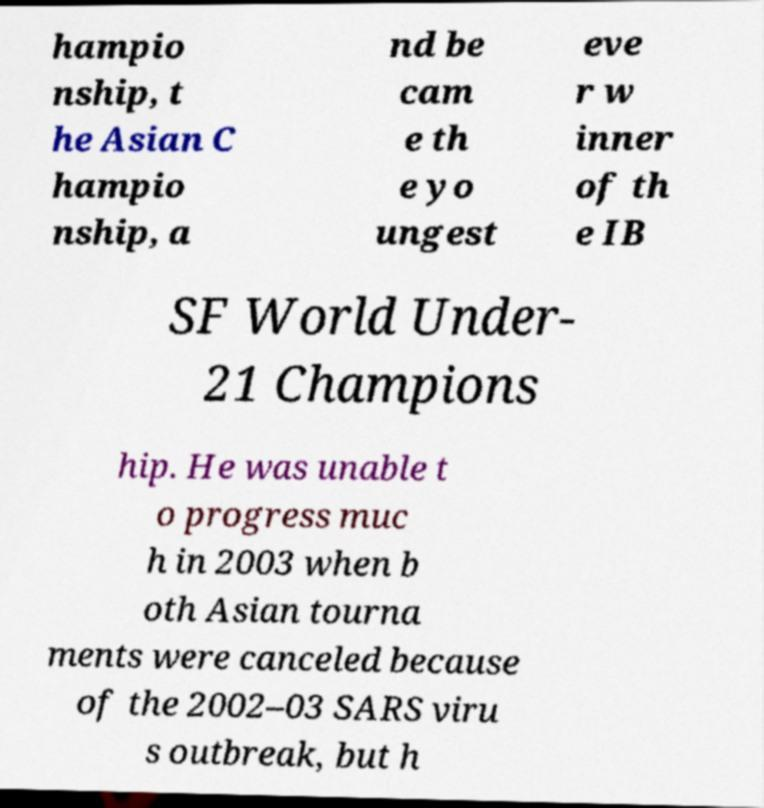I need the written content from this picture converted into text. Can you do that? hampio nship, t he Asian C hampio nship, a nd be cam e th e yo ungest eve r w inner of th e IB SF World Under- 21 Champions hip. He was unable t o progress muc h in 2003 when b oth Asian tourna ments were canceled because of the 2002–03 SARS viru s outbreak, but h 